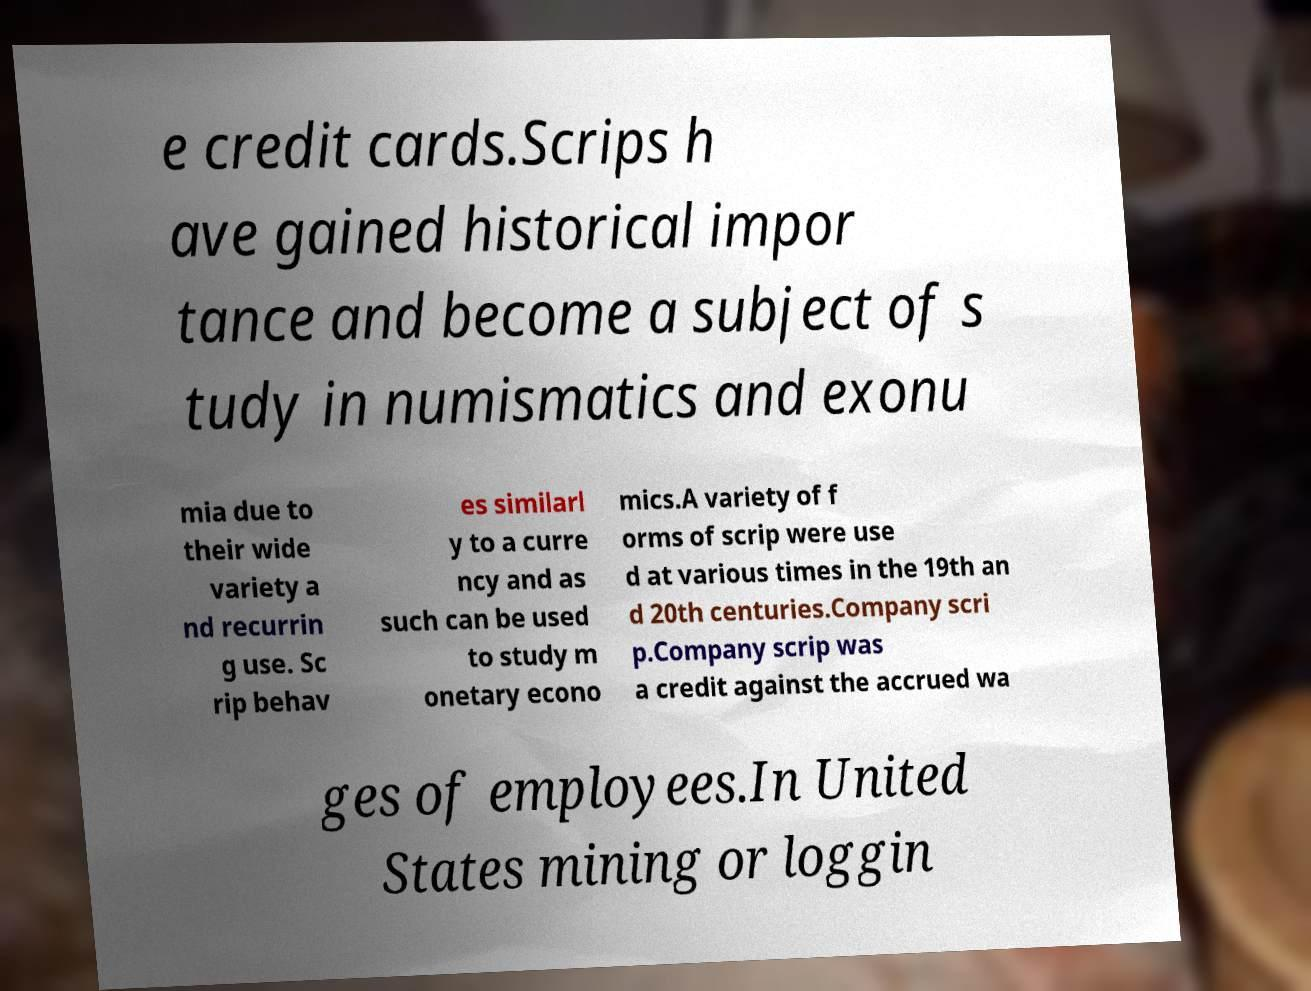Please read and relay the text visible in this image. What does it say? e credit cards.Scrips h ave gained historical impor tance and become a subject of s tudy in numismatics and exonu mia due to their wide variety a nd recurrin g use. Sc rip behav es similarl y to a curre ncy and as such can be used to study m onetary econo mics.A variety of f orms of scrip were use d at various times in the 19th an d 20th centuries.Company scri p.Company scrip was a credit against the accrued wa ges of employees.In United States mining or loggin 